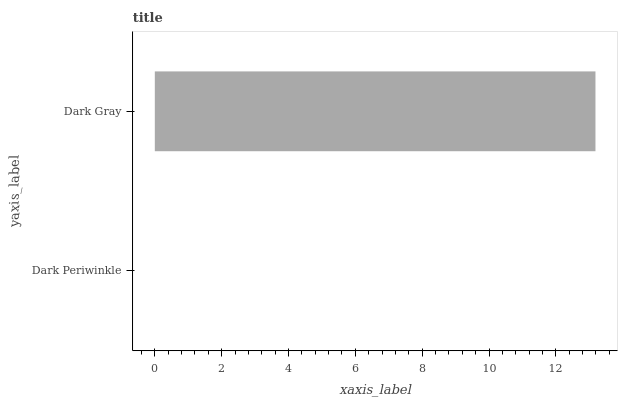Is Dark Periwinkle the minimum?
Answer yes or no. Yes. Is Dark Gray the maximum?
Answer yes or no. Yes. Is Dark Gray the minimum?
Answer yes or no. No. Is Dark Gray greater than Dark Periwinkle?
Answer yes or no. Yes. Is Dark Periwinkle less than Dark Gray?
Answer yes or no. Yes. Is Dark Periwinkle greater than Dark Gray?
Answer yes or no. No. Is Dark Gray less than Dark Periwinkle?
Answer yes or no. No. Is Dark Gray the high median?
Answer yes or no. Yes. Is Dark Periwinkle the low median?
Answer yes or no. Yes. Is Dark Periwinkle the high median?
Answer yes or no. No. Is Dark Gray the low median?
Answer yes or no. No. 